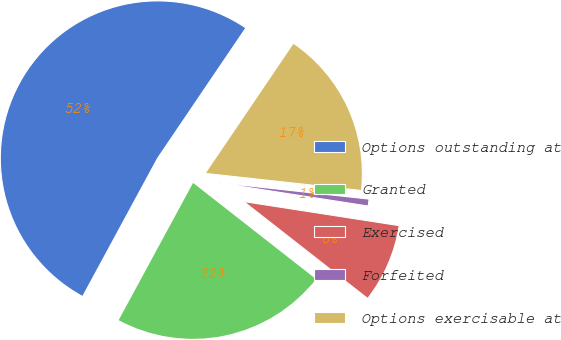Convert chart. <chart><loc_0><loc_0><loc_500><loc_500><pie_chart><fcel>Options outstanding at<fcel>Granted<fcel>Exercised<fcel>Forfeited<fcel>Options exercisable at<nl><fcel>51.57%<fcel>22.34%<fcel>8.12%<fcel>0.71%<fcel>17.26%<nl></chart> 